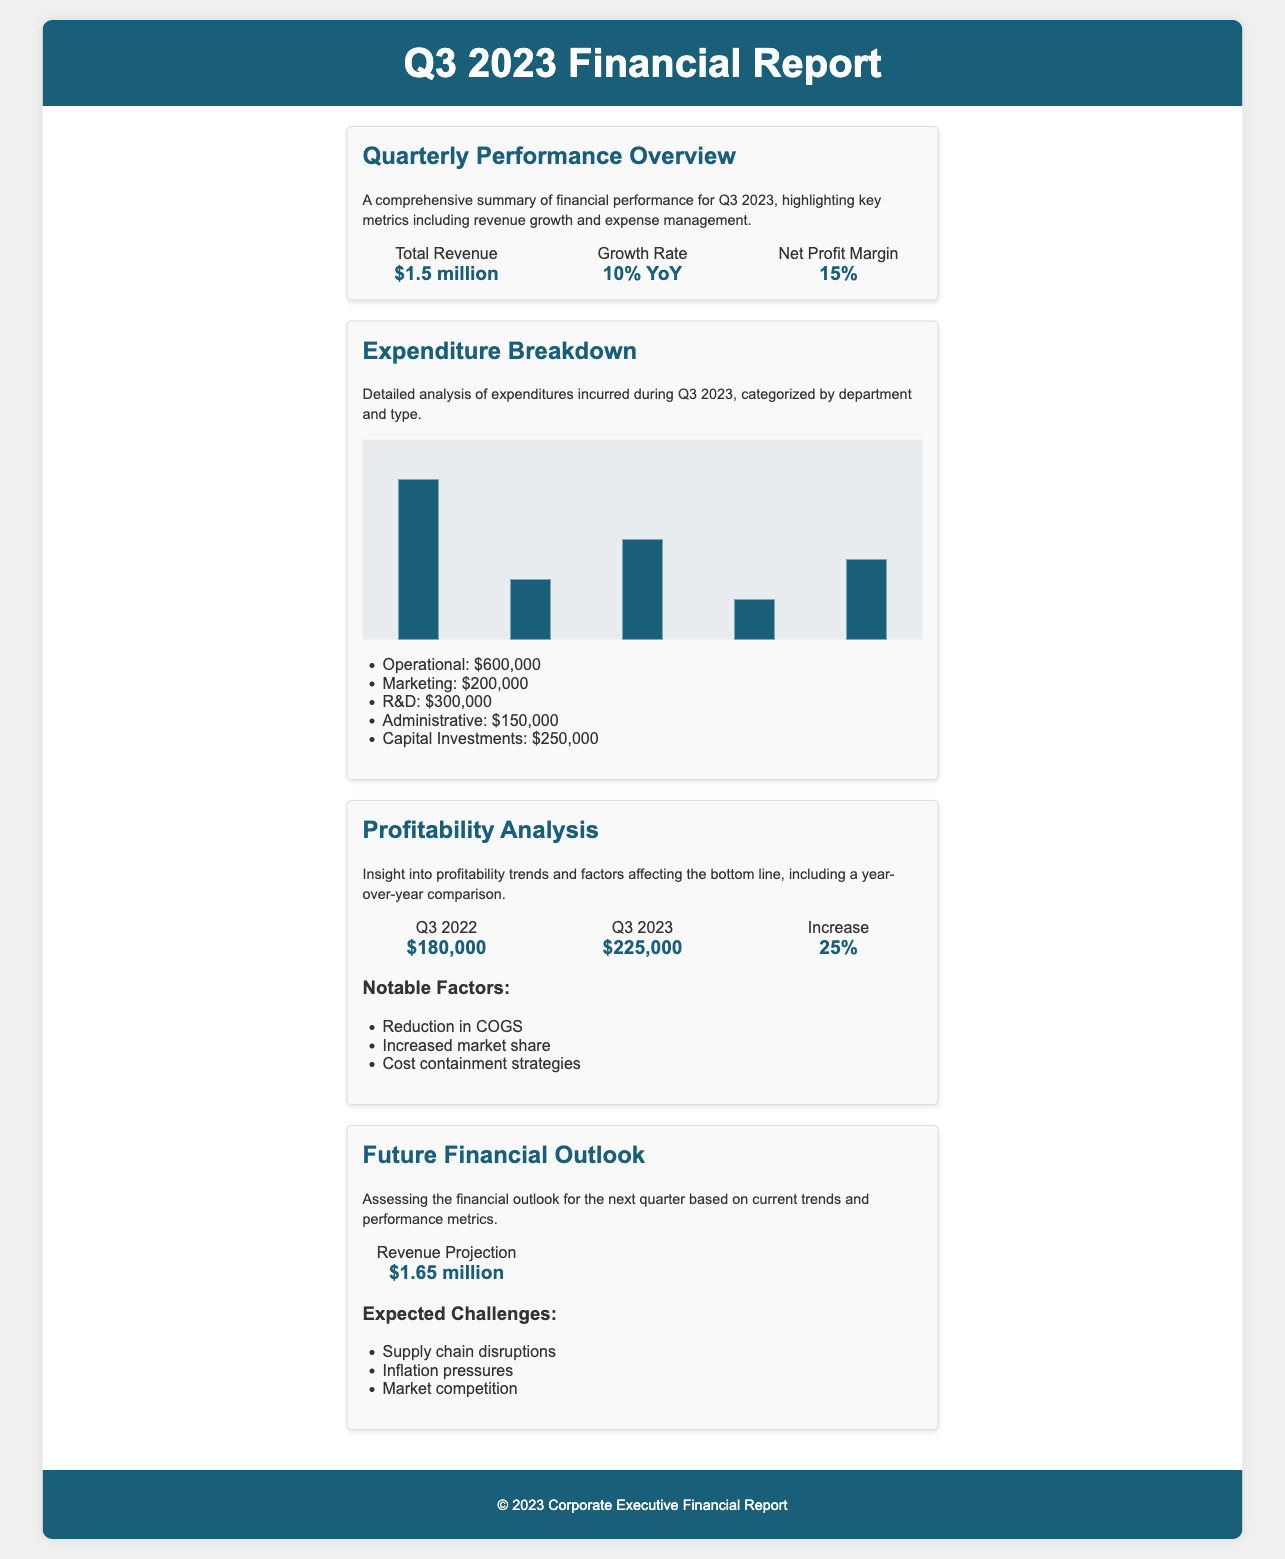What is the total revenue for Q3 2023? The total revenue is explicitly stated in the document as $1.5 million.
Answer: $1.5 million What is the growth rate year-over-year? The document provides the growth rate as 10% compared to the previous year.
Answer: 10% YoY What is the net profit margin reported? The net profit margin is mentioned as 15% in the financial overview section.
Answer: 15% How much was spent on Marketing? The expenditure breakdown specifies that $200,000 was spent on Marketing.
Answer: $200,000 What was the net profit for Q3 2022? The document indicates that the net profit for Q3 2022 was $180,000.
Answer: $180,000 What is the projected revenue for the next quarter? The future financial outlook provides a revenue projection of $1.65 million.
Answer: $1.65 million By what percentage did the net profit increase from Q3 2022 to Q3 2023? The profitability analysis states that the increase was 25% compared to the previous year.
Answer: 25% What are two expected challenges for the next quarter? The document lists supply chain disruptions and inflation pressures as challenges.
Answer: Supply chain disruptions, inflation pressures What type of document is this? The content is a quarterly financial report focusing on performance metrics and profitability analysis.
Answer: Quarterly financial report 